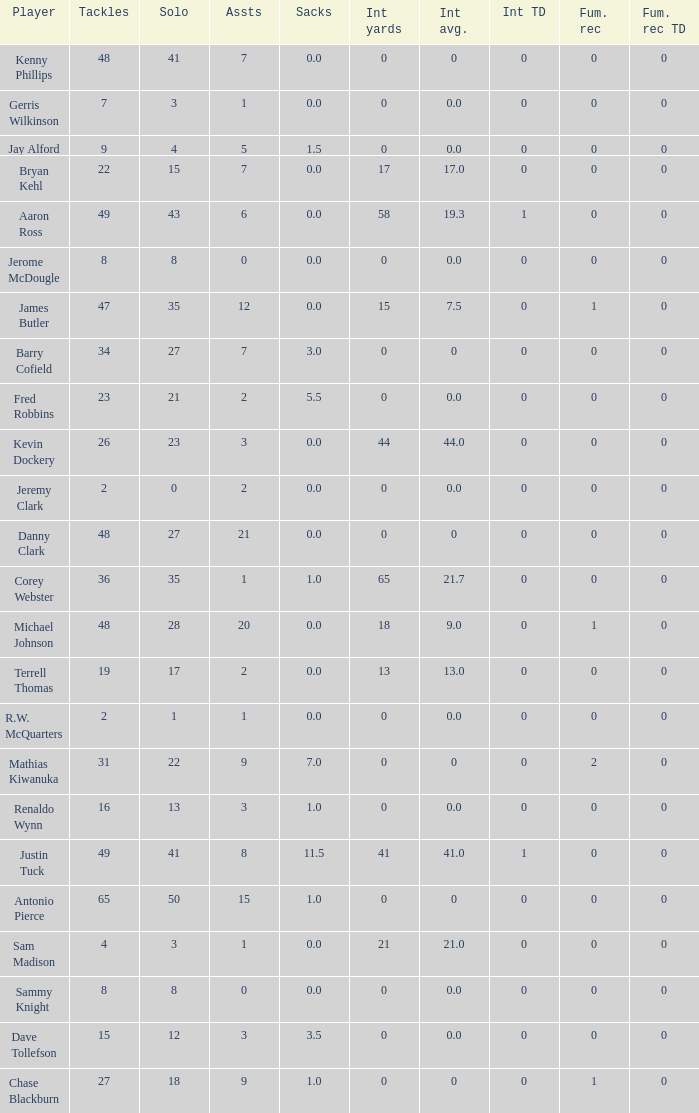What is the sum for the int yards that has an assts more than 3, and player Jay Alford? 0.0. 